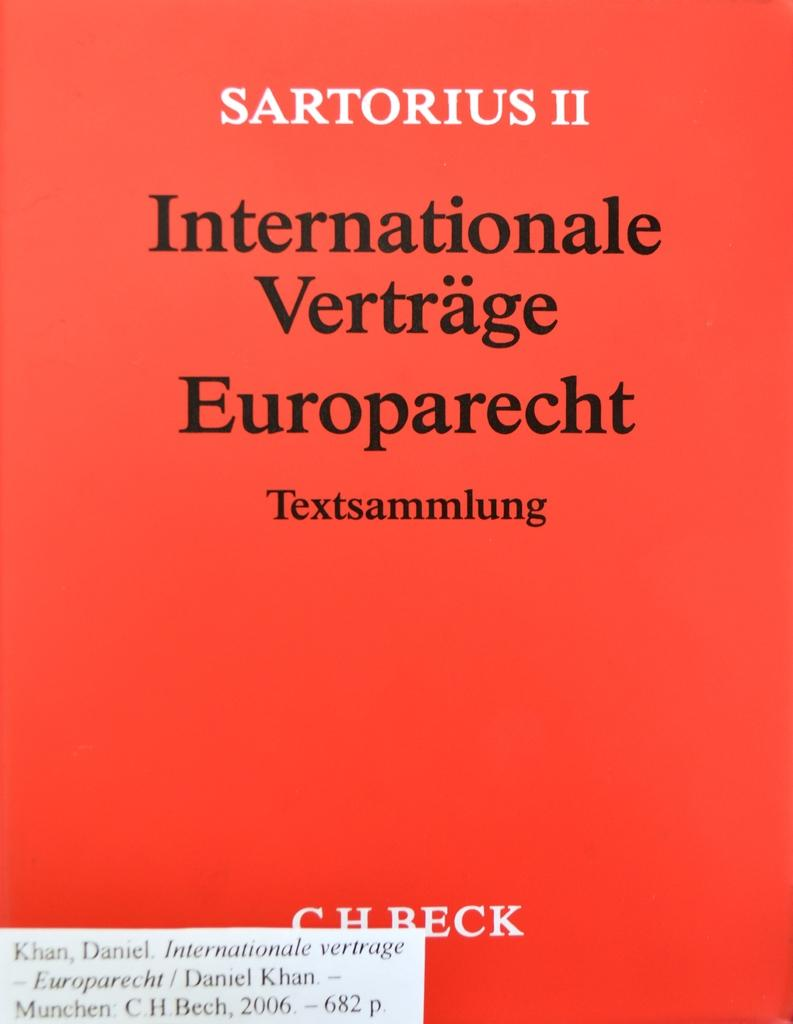What type of page is shown in the image? The image is the top cover page of a book. What can be found on the cover page? There is text on the cover page. What color is the text on the cover page? The text is in black color. Where is the kettle placed on the cover page? There is no kettle present on the cover page; it is a book cover with text. Can you see any shelves on the cover page? There are no shelves visible on the cover page; it is a book cover with text. 